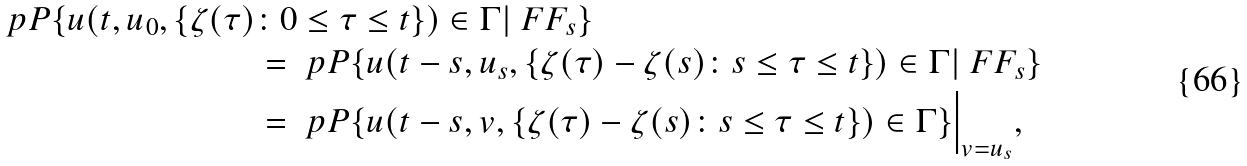<formula> <loc_0><loc_0><loc_500><loc_500>\ p P \{ u ( t , u _ { 0 } , \{ \zeta ( \tau ) & \colon 0 \leq \tau \leq t \} ) \in \Gamma | \ F F _ { s } \} \\ & = \ p P \{ u ( t - s , u _ { s } , \{ \zeta ( \tau ) - \zeta ( s ) \colon s \leq \tau \leq t \} ) \in \Gamma | \ F F _ { s } \} \\ & = \ p P \{ u ( t - s , v , \{ \zeta ( \tau ) - \zeta ( s ) \colon s \leq \tau \leq t \} ) \in \Gamma \} \Big | _ { v = u _ { s } } ,</formula> 